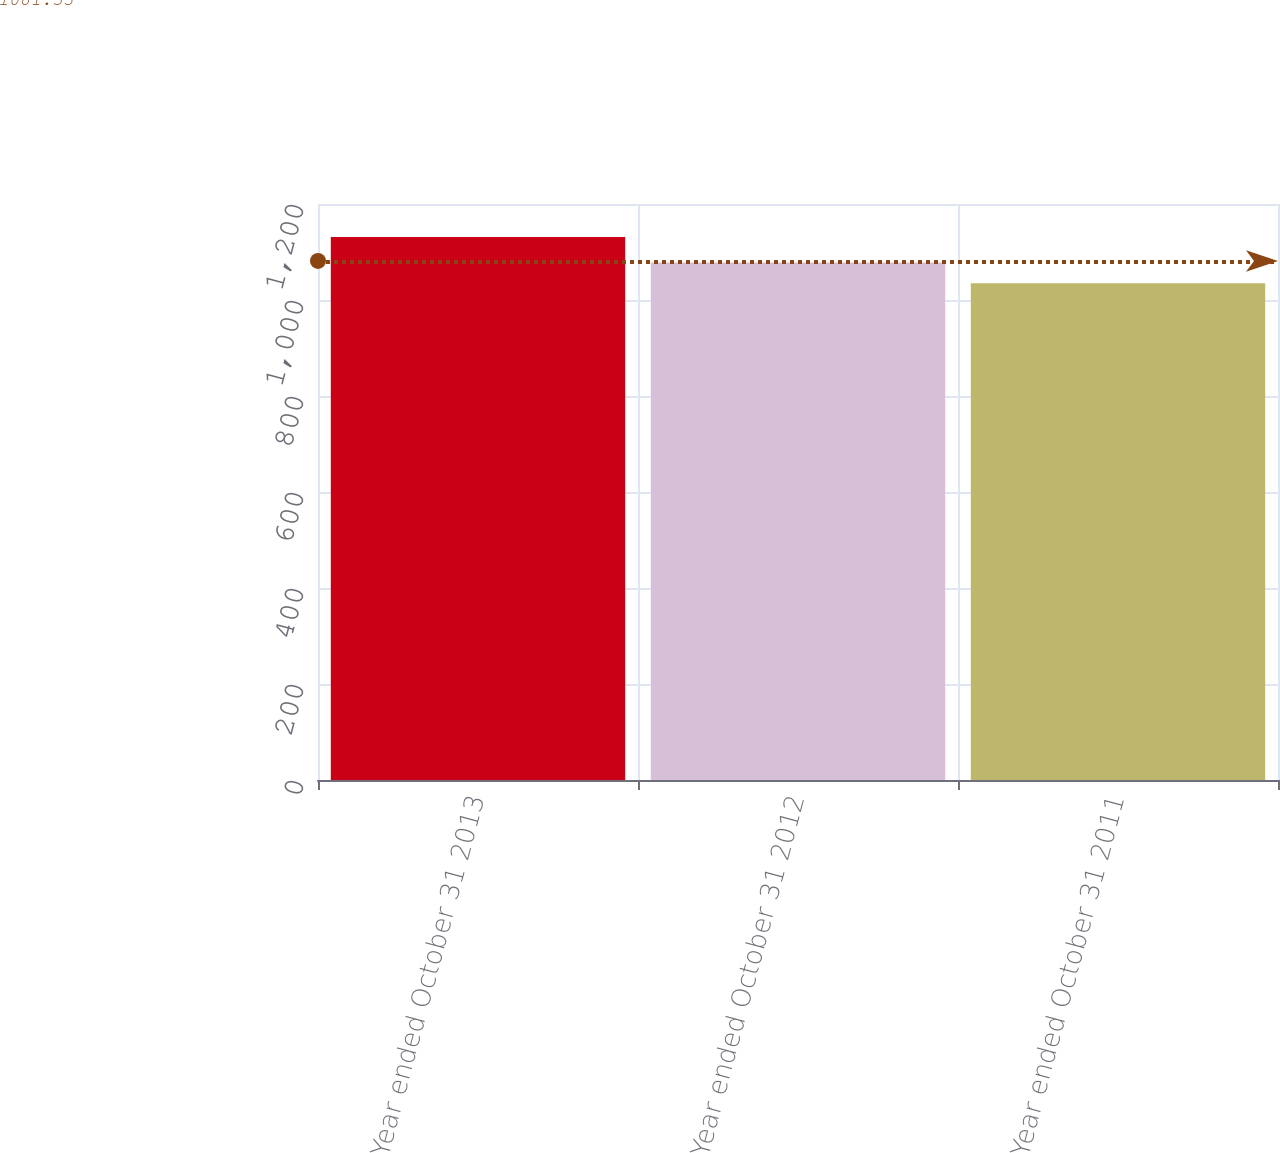Convert chart. <chart><loc_0><loc_0><loc_500><loc_500><bar_chart><fcel>Year ended October 31 2013<fcel>Year ended October 31 2012<fcel>Year ended October 31 2011<nl><fcel>1131<fcel>1078<fcel>1035<nl></chart> 